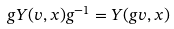<formula> <loc_0><loc_0><loc_500><loc_500>g Y ( v , x ) g ^ { - 1 } = Y ( g v , x )</formula> 